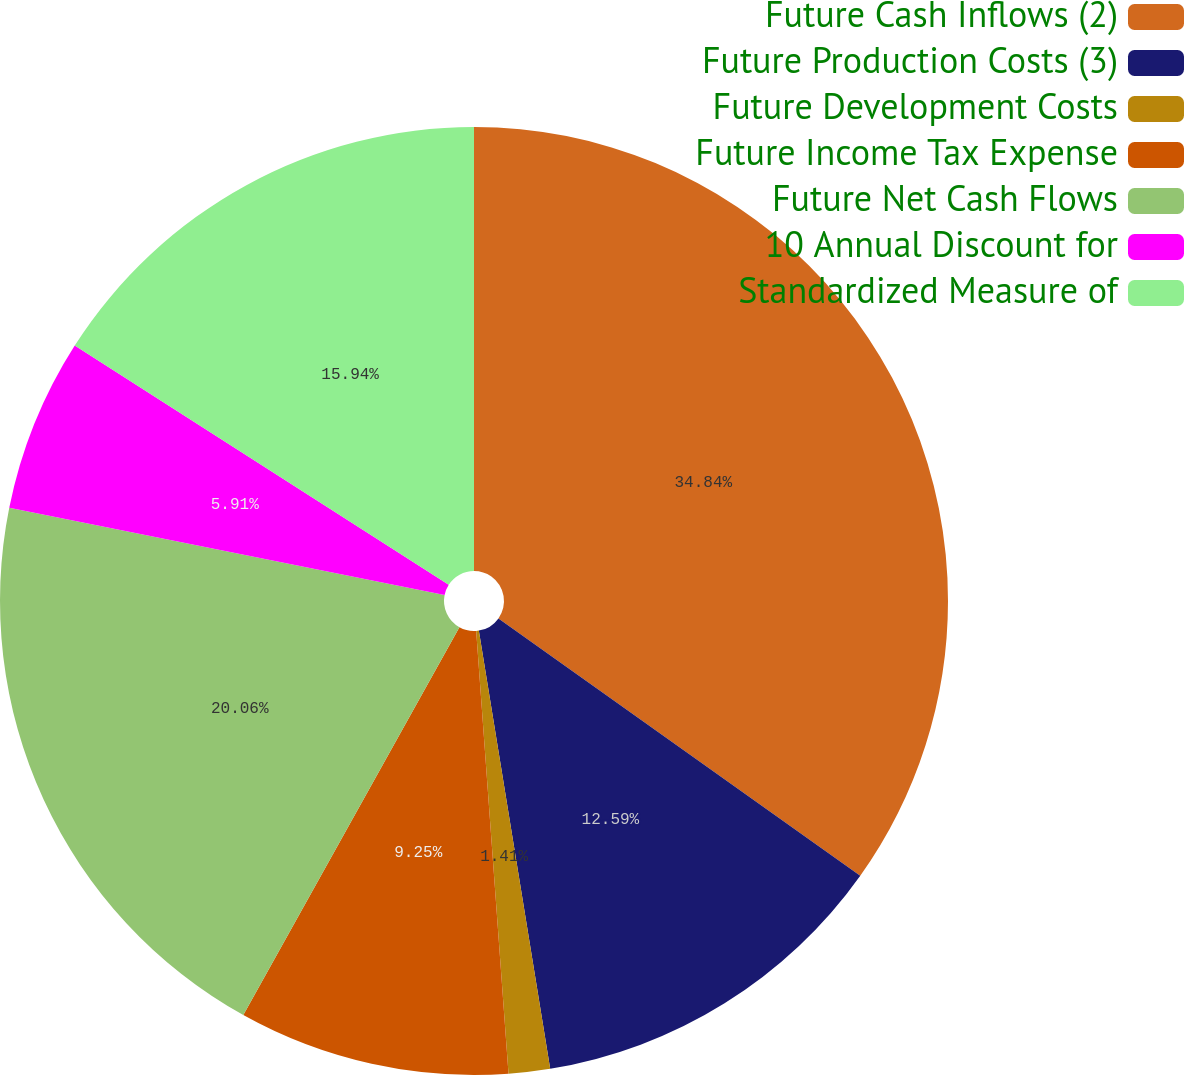Convert chart. <chart><loc_0><loc_0><loc_500><loc_500><pie_chart><fcel>Future Cash Inflows (2)<fcel>Future Production Costs (3)<fcel>Future Development Costs<fcel>Future Income Tax Expense<fcel>Future Net Cash Flows<fcel>10 Annual Discount for<fcel>Standardized Measure of<nl><fcel>34.84%<fcel>12.59%<fcel>1.41%<fcel>9.25%<fcel>20.06%<fcel>5.91%<fcel>15.94%<nl></chart> 